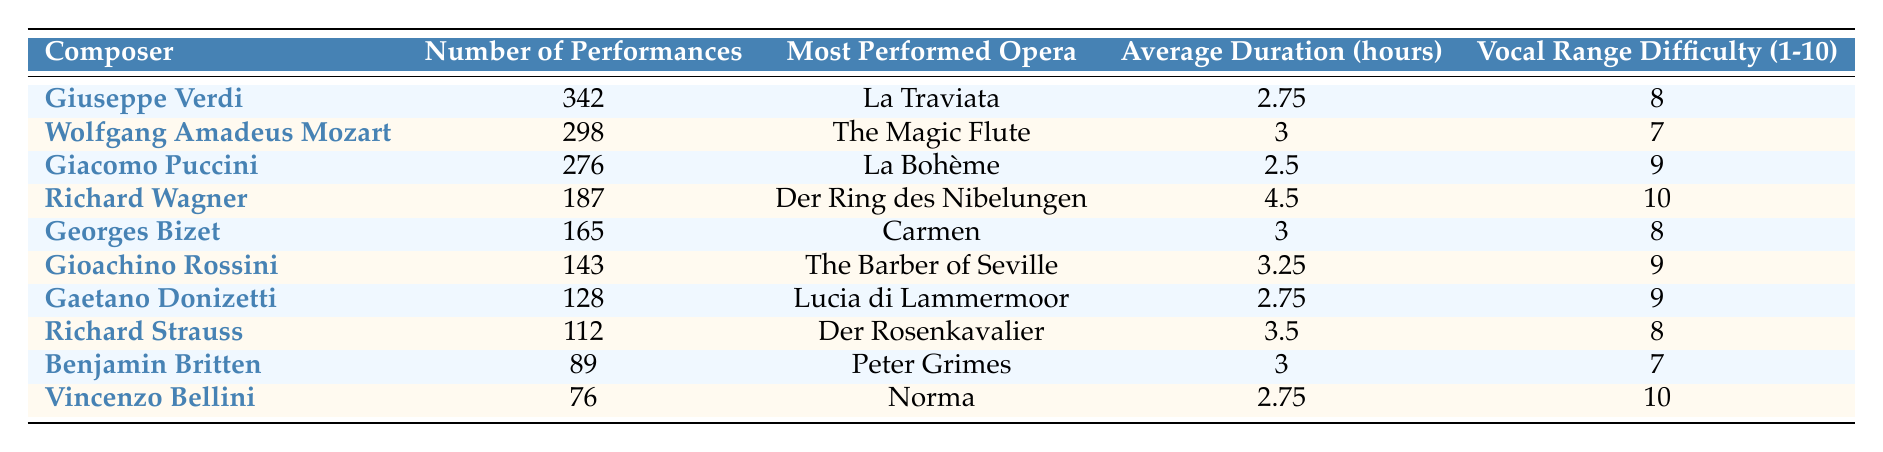What is the most performed opera by Giuseppe Verdi? The table indicates that the most performed opera by Giuseppe Verdi is "La Traviata," as it is directly listed under the "Most Performed Opera" column for Verdi.
Answer: La Traviata Which composer has the highest number of performances? Giuseppe Verdi has the highest number of performances at 342, which is the largest figure in the "Number of Performances" column.
Answer: 342 Is the average duration of "Carmen" longer than that of "La Bohème"? "Carmen" has an average duration of 3 hours, while "La Bohème" has an average duration of 2.5 hours. Since 3 > 2.5, the statement is true.
Answer: Yes What is the average vocal range difficulty of the operas by Verdi and Puccini? Verdi has a vocal range difficulty of 8, and Puccini has a difficulty of 9. To find the average, sum these two scores: (8 + 9) / 2 = 8.5.
Answer: 8.5 How many more performances did Mozart have compared to Bizet? Mozart had 298 performances and Bizet had 165. Subtracting the two gives: 298 - 165 = 133.
Answer: 133 Is "Der Ring des Nibelungen" performed more than 200 times? The table indicates that "Der Ring des Nibelungen" has 187 performances, which is less than 200. Thus, the statement is false.
Answer: No What is the total number of performances of the operas by Gioachino Rossini and Benjamin Britten? Rossini has 143 performances and Britten has 89. To find the total, we add the two numbers: 143 + 89 = 232.
Answer: 232 Which composer has the most challenging vocal range based on the table? Richard Wagner has the highest vocal range difficulty rated at 10, based on the "Vocal Range Difficulty" column.
Answer: Richard Wagner What is the median average duration of the operas listed? The average durations in hours for all composers are: 2.75, 3, 2.5, 4.5, 3, 3.25, 2.75, 3.5, 3, 2.75. First, we organize them in order: 2.5, 2.75, 2.75, 2.75, 3, 3, 3.25, 3.5, 4.5. Since there are 10 values, the median will be the average of the 5th and 6th numbers: (3 + 3) / 2 = 3.
Answer: 3 